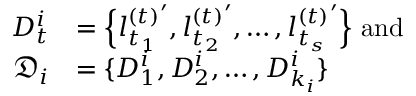Convert formula to latex. <formula><loc_0><loc_0><loc_500><loc_500>\begin{array} { r l } { D _ { t } ^ { i } } & { = \left \{ { l _ { t _ { 1 } } ^ { ( t ) } } ^ { \prime } , { l _ { t _ { 2 } } ^ { ( t ) } } ^ { \prime } , \dots , { l _ { t _ { s } } ^ { ( t ) } } ^ { \prime } \right \} a n d } \\ { \mathfrak { D } _ { i } } & { = \{ D _ { 1 } ^ { i } , D _ { 2 } ^ { i } , \dots , D _ { k _ { i } } ^ { i } \} } \end{array}</formula> 